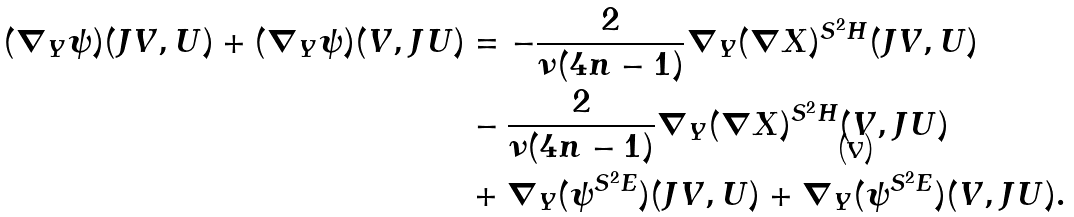Convert formula to latex. <formula><loc_0><loc_0><loc_500><loc_500>( \nabla _ { Y } \psi ) ( J V , U ) + ( \nabla _ { Y } \psi ) ( V , J U ) & = - \frac { 2 } { \nu ( 4 n - 1 ) } \nabla _ { Y } ( \nabla X ) ^ { S ^ { 2 } H } ( J V , U ) \\ & - \frac { 2 } { \nu ( 4 n - 1 ) } \nabla _ { Y } ( \nabla X ) ^ { S ^ { 2 } H } ( V , J U ) \\ & + \nabla _ { Y } ( \psi ^ { S ^ { 2 } E } ) ( J V , U ) + \nabla _ { Y } ( \psi ^ { S ^ { 2 } E } ) ( V , J U ) . \\</formula> 